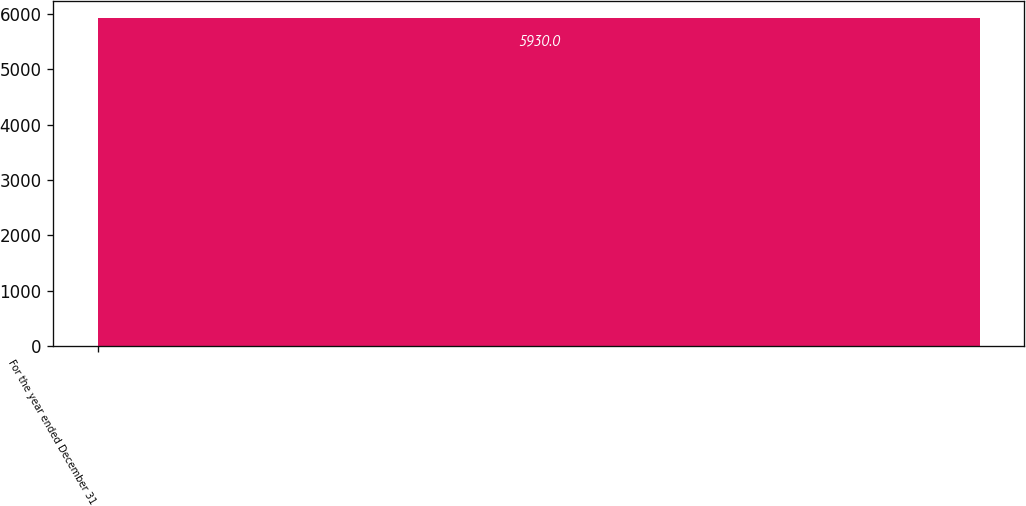<chart> <loc_0><loc_0><loc_500><loc_500><bar_chart><fcel>For the year ended December 31<nl><fcel>5930<nl></chart> 